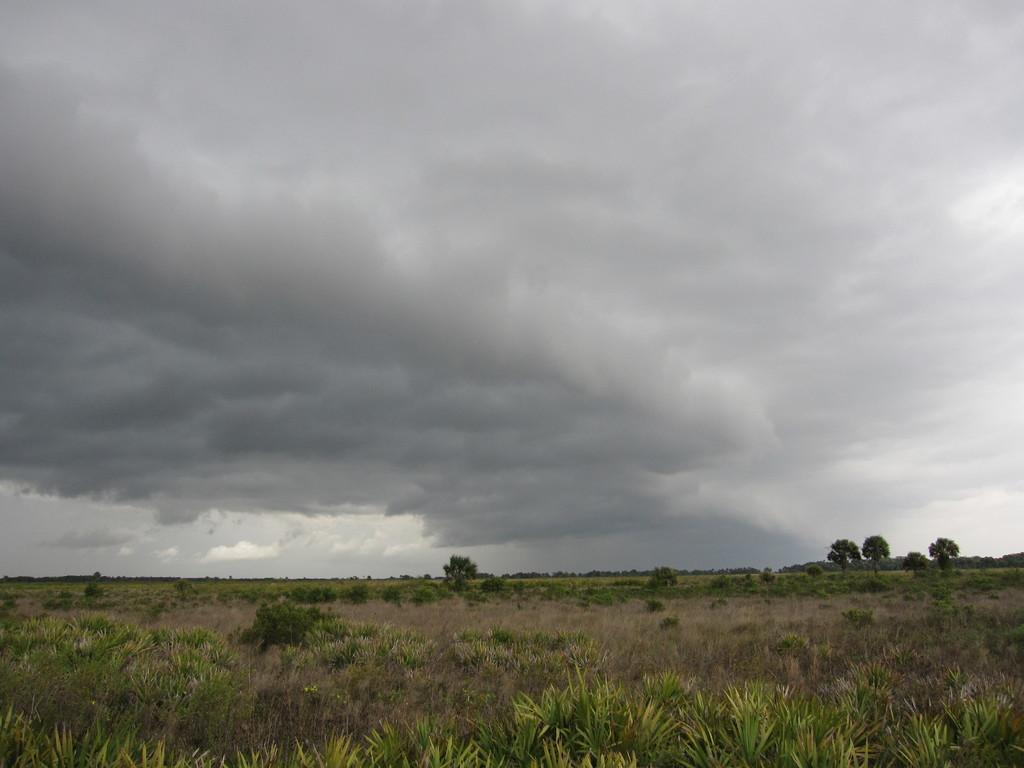What type of vegetation can be seen in the image? There are trees and plants in the image. What is the condition of the sky in the image? The sky is cloudy in the image. Can you see any snails crawling on the plants in the image? There are no snails visible in the image. What type of rice is being grown in the image? There is no rice present in the image. 